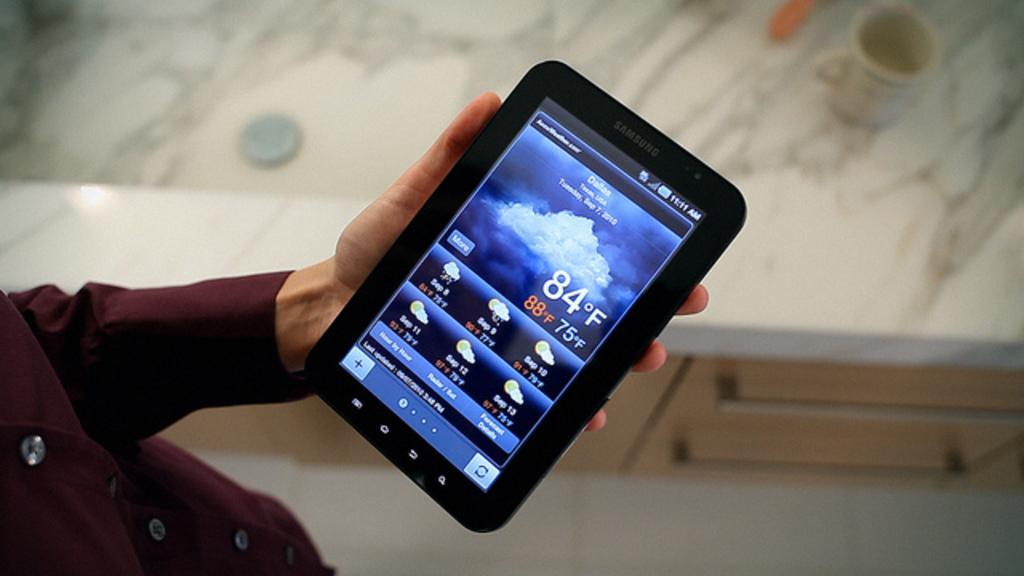In one or two sentences, can you explain what this image depicts? A human is holding the Samsung tab, this person wore the shirt. 